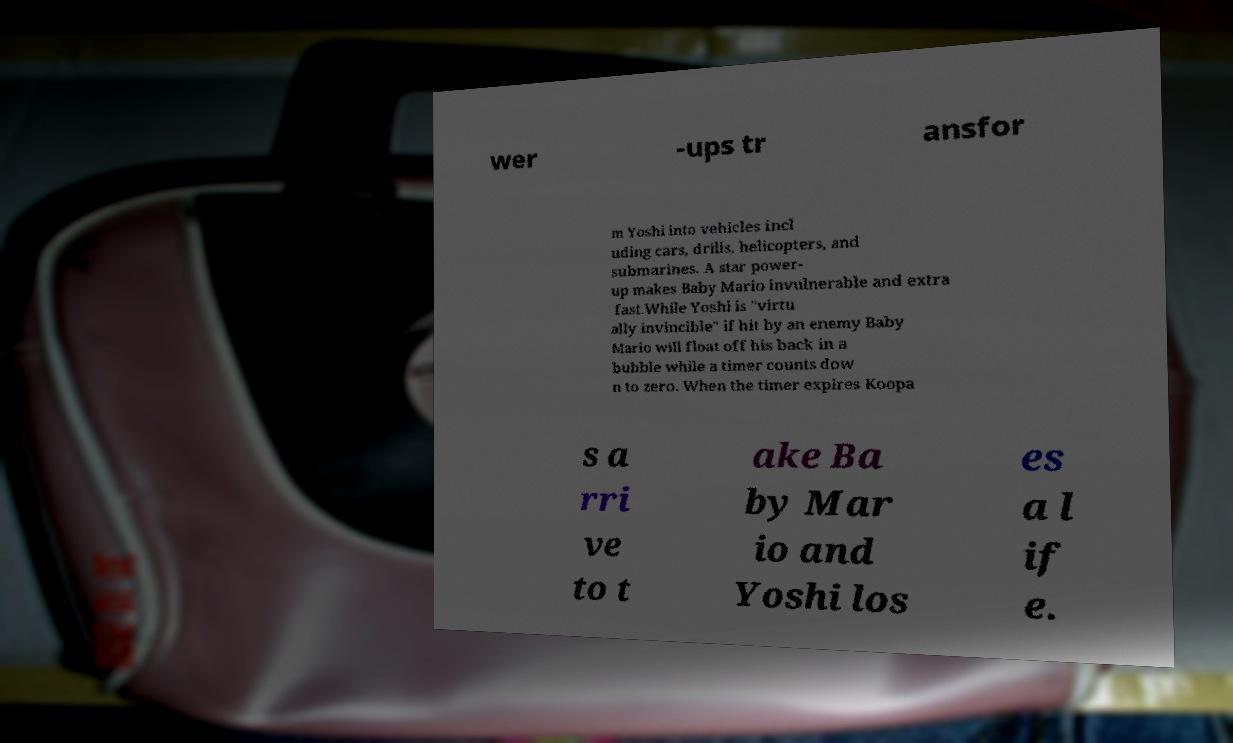Can you read and provide the text displayed in the image?This photo seems to have some interesting text. Can you extract and type it out for me? wer -ups tr ansfor m Yoshi into vehicles incl uding cars, drills, helicopters, and submarines. A star power- up makes Baby Mario invulnerable and extra fast.While Yoshi is "virtu ally invincible" if hit by an enemy Baby Mario will float off his back in a bubble while a timer counts dow n to zero. When the timer expires Koopa s a rri ve to t ake Ba by Mar io and Yoshi los es a l if e. 